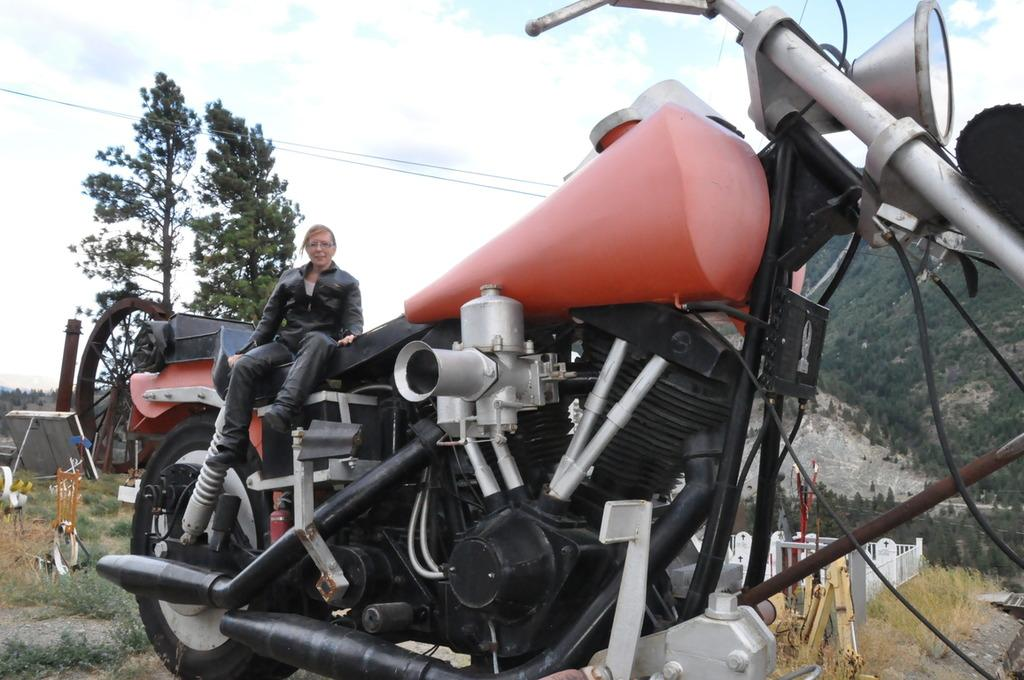Who is the main subject in the image? There is a woman in the image. What is the woman doing in the image? The woman is sitting on a motorcycle. What can be seen in the background of the image? There are trees in the background of the image. How would you describe the weather in the image? The sky is clear in the image, suggesting good weather. What type of hook is the woman using to climb the tree in the image? There is no hook or tree present in the image; the woman is sitting on a motorcycle with trees in the background. 